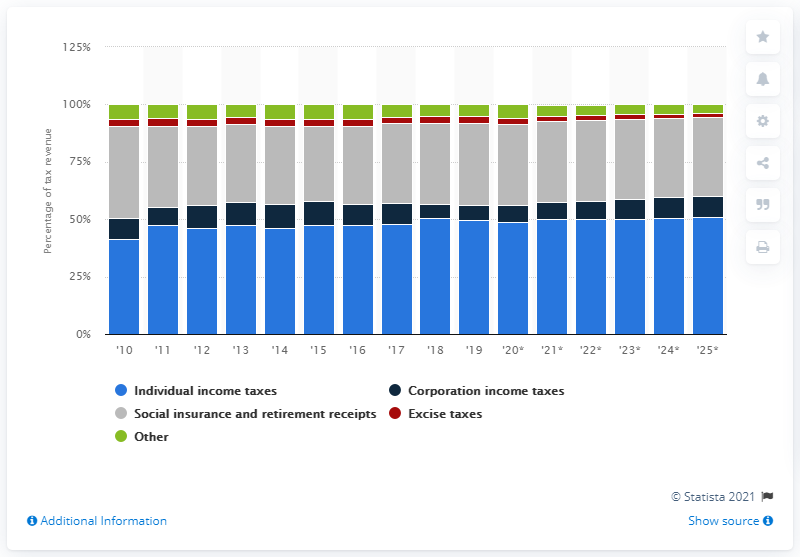Identify some key points in this picture. In 2019, excise taxes accounted for 2.9% of the total tax revenue collected by the government. 